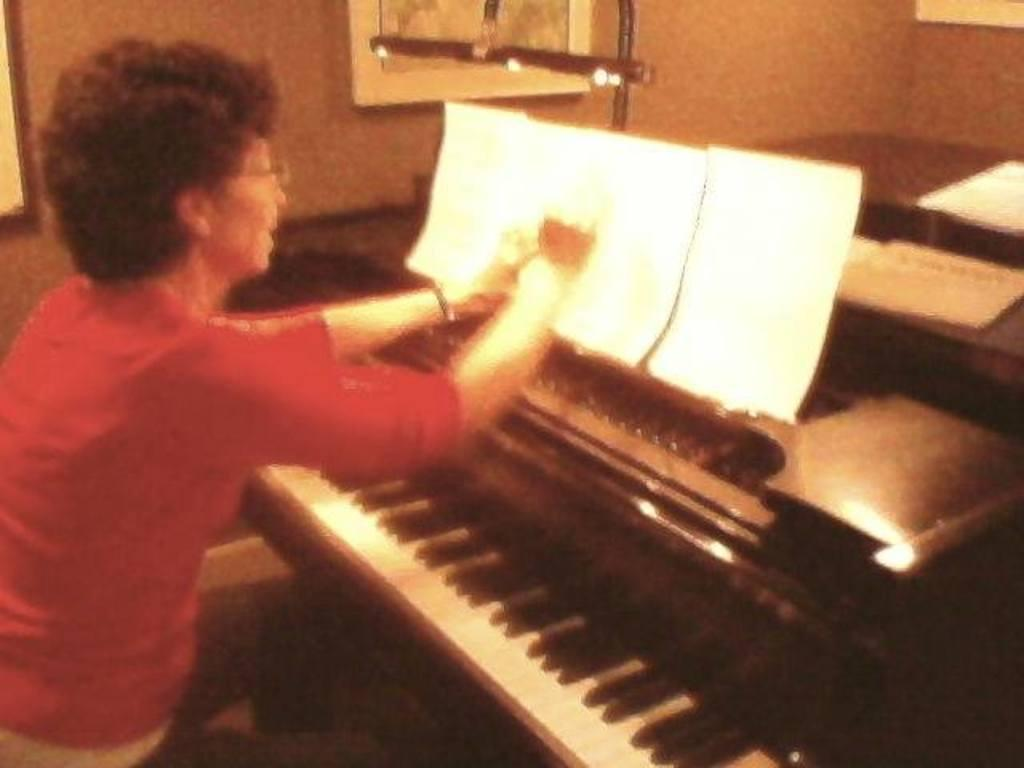Who is present in the image? There is a woman in the image. What objects can be seen with the woman? There are papers and a piano in the image. Where is the faucet located in the image? There is no faucet present in the image. What type of quilt is being used to cover the piano? There is no quilt present in the image; it only features a woman, papers, and a piano. 